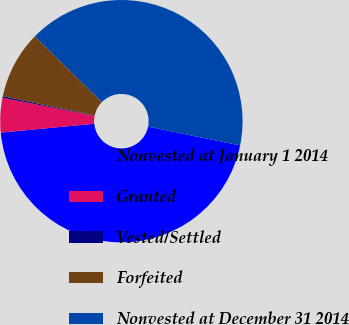Convert chart. <chart><loc_0><loc_0><loc_500><loc_500><pie_chart><fcel>Nonvested at January 1 2014<fcel>Granted<fcel>Vested/Settled<fcel>Forfeited<fcel>Nonvested at December 31 2014<nl><fcel>45.29%<fcel>4.61%<fcel>0.2%<fcel>9.03%<fcel>40.87%<nl></chart> 